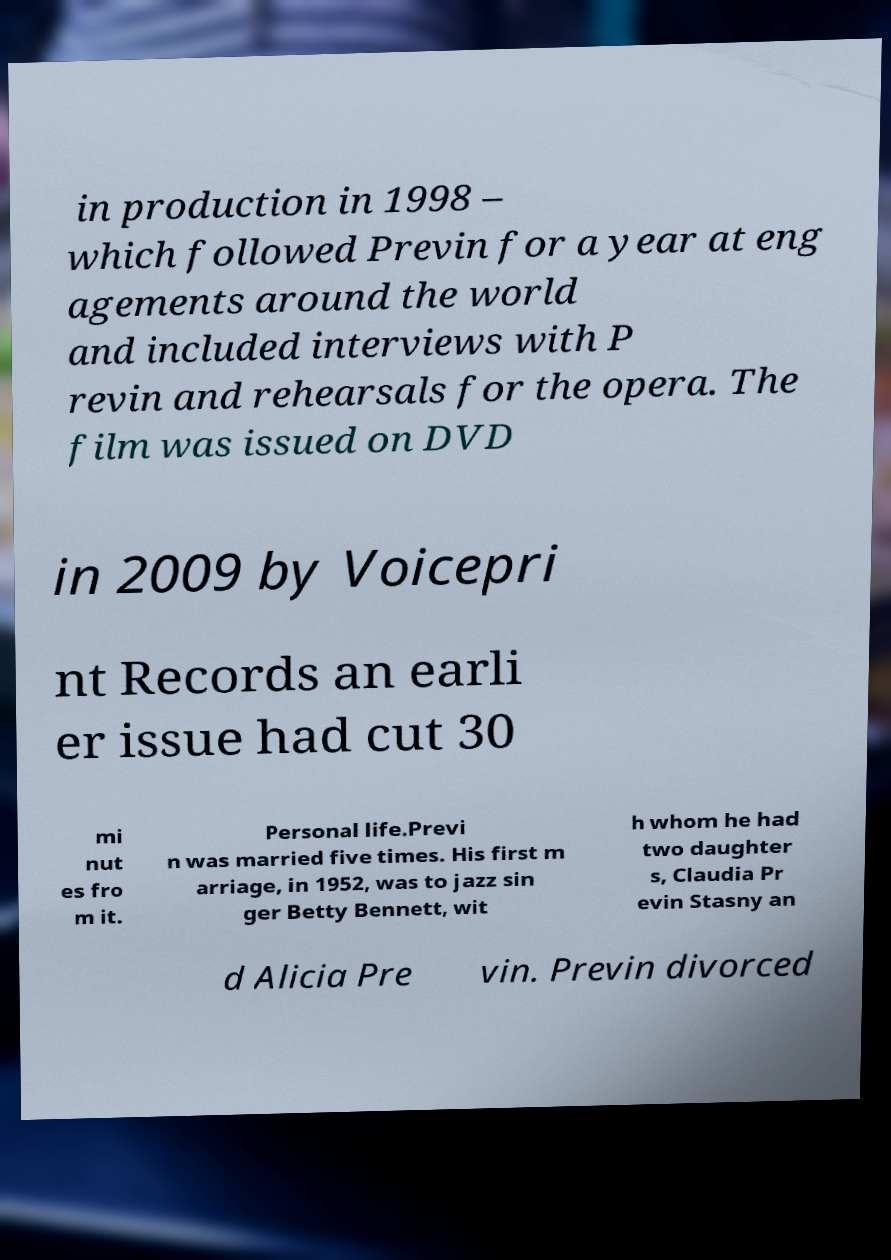There's text embedded in this image that I need extracted. Can you transcribe it verbatim? in production in 1998 – which followed Previn for a year at eng agements around the world and included interviews with P revin and rehearsals for the opera. The film was issued on DVD in 2009 by Voicepri nt Records an earli er issue had cut 30 mi nut es fro m it. Personal life.Previ n was married five times. His first m arriage, in 1952, was to jazz sin ger Betty Bennett, wit h whom he had two daughter s, Claudia Pr evin Stasny an d Alicia Pre vin. Previn divorced 